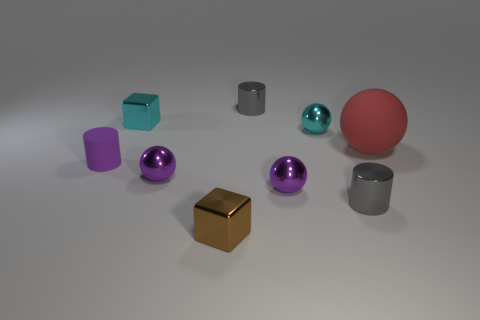Subtract all cyan cubes. How many cubes are left? 1 Subtract all tiny shiny cylinders. How many cylinders are left? 1 Add 1 small gray blocks. How many objects exist? 10 Subtract all balls. How many objects are left? 5 Subtract 2 balls. How many balls are left? 2 Subtract all brown cylinders. Subtract all cyan cubes. How many cylinders are left? 3 Subtract all brown spheres. How many purple cubes are left? 0 Subtract all purple things. Subtract all cyan metal cubes. How many objects are left? 5 Add 3 tiny brown cubes. How many tiny brown cubes are left? 4 Add 8 big gray shiny cylinders. How many big gray shiny cylinders exist? 8 